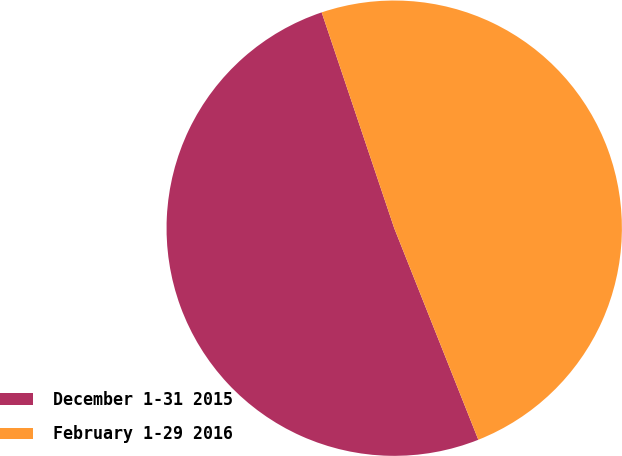<chart> <loc_0><loc_0><loc_500><loc_500><pie_chart><fcel>December 1-31 2015<fcel>February 1-29 2016<nl><fcel>50.86%<fcel>49.14%<nl></chart> 